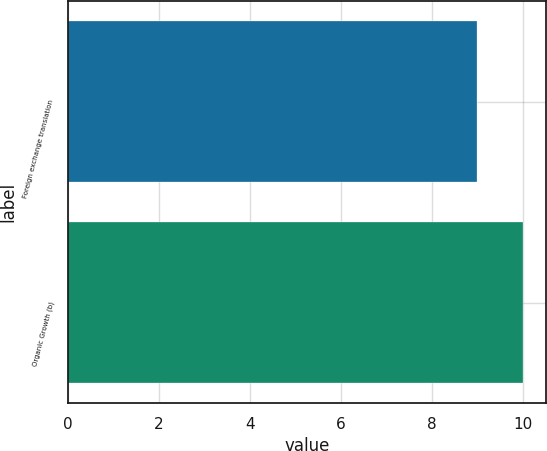Convert chart to OTSL. <chart><loc_0><loc_0><loc_500><loc_500><bar_chart><fcel>Foreign exchange translation<fcel>Organic Growth (b)<nl><fcel>9<fcel>10<nl></chart> 